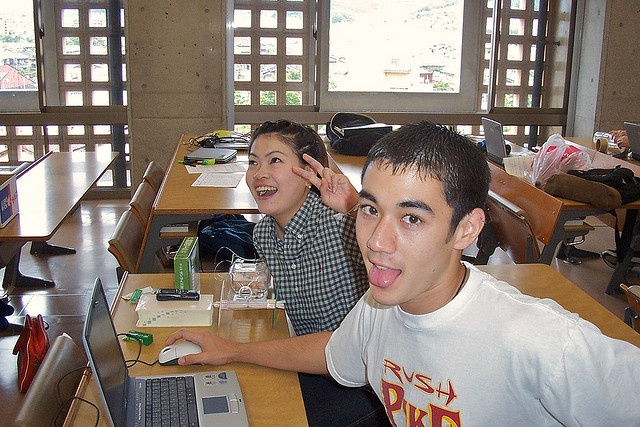Describe the objects in this image and their specific colors. I can see people in ivory, darkgray, lightgray, brown, and tan tones, people in ivory, black, gray, and darkgray tones, laptop in ivory, gray, darkgray, black, and maroon tones, chair in ivory, maroon, brown, and black tones, and chair in ivory, black, gray, and maroon tones in this image. 